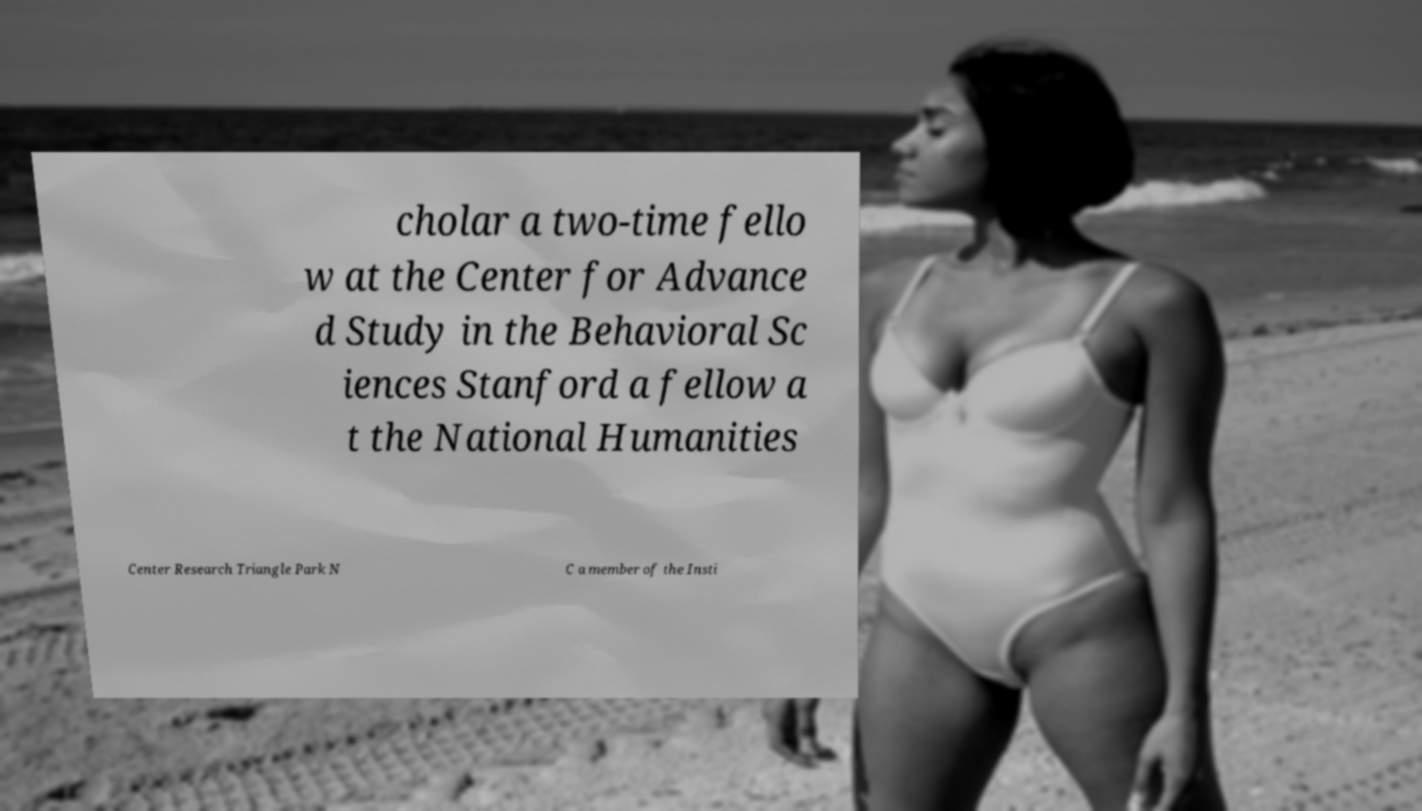Can you read and provide the text displayed in the image?This photo seems to have some interesting text. Can you extract and type it out for me? cholar a two-time fello w at the Center for Advance d Study in the Behavioral Sc iences Stanford a fellow a t the National Humanities Center Research Triangle Park N C a member of the Insti 